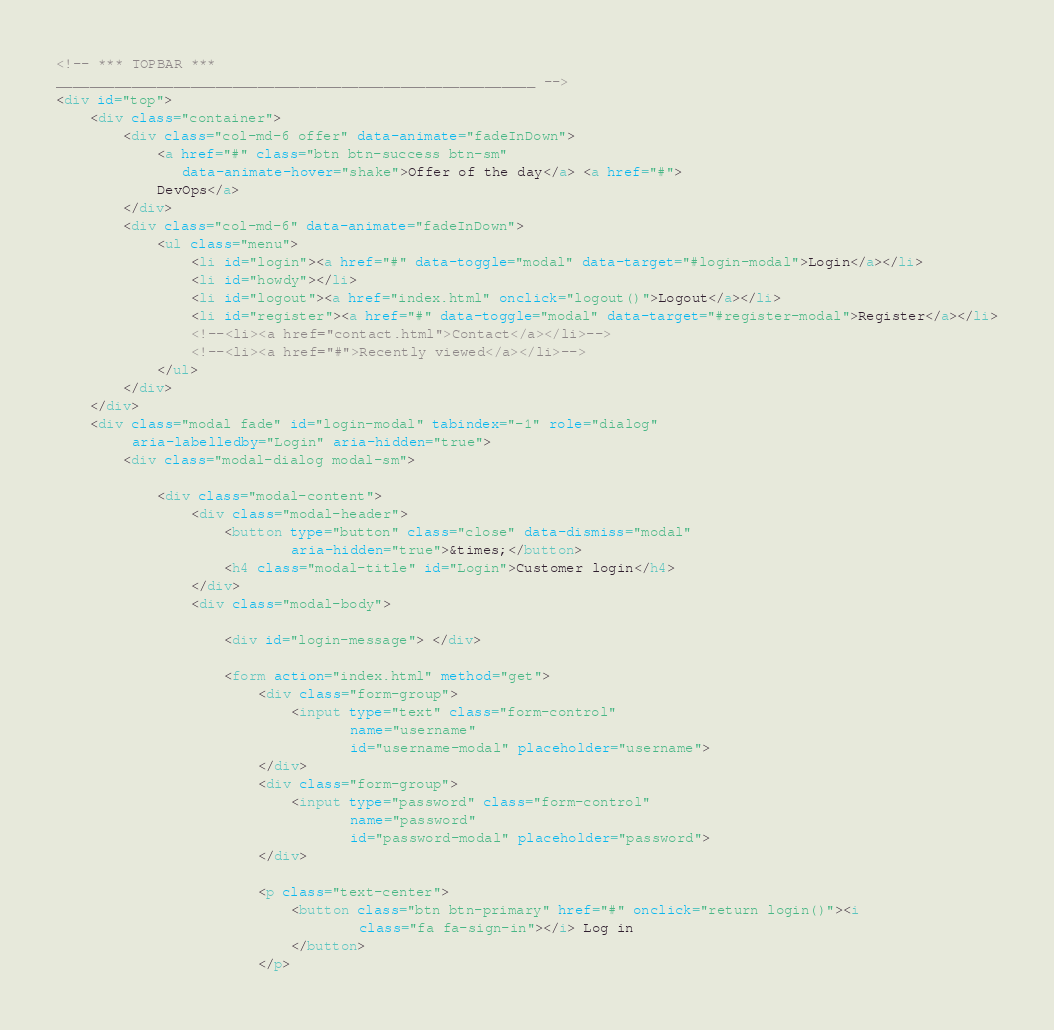<code> <loc_0><loc_0><loc_500><loc_500><_HTML_><!-- *** TOPBAR ***
_________________________________________________________ -->
<div id="top">
    <div class="container">
        <div class="col-md-6 offer" data-animate="fadeInDown">
            <a href="#" class="btn btn-success btn-sm"
               data-animate-hover="shake">Offer of the day</a> <a href="#">
            DevOps</a>
        </div>
        <div class="col-md-6" data-animate="fadeInDown">
            <ul class="menu">
                <li id="login"><a href="#" data-toggle="modal" data-target="#login-modal">Login</a></li>
                <li id="howdy"></li>
                <li id="logout"><a href="index.html" onclick="logout()">Logout</a></li>
                <li id="register"><a href="#" data-toggle="modal" data-target="#register-modal">Register</a></li>
                <!--<li><a href="contact.html">Contact</a></li>-->
                <!--<li><a href="#">Recently viewed</a></li>-->
            </ul>
        </div>
    </div>
    <div class="modal fade" id="login-modal" tabindex="-1" role="dialog"
         aria-labelledby="Login" aria-hidden="true">
        <div class="modal-dialog modal-sm">

            <div class="modal-content">
                <div class="modal-header">
                    <button type="button" class="close" data-dismiss="modal"
                            aria-hidden="true">&times;</button>
                    <h4 class="modal-title" id="Login">Customer login</h4>
                </div>
                <div class="modal-body">

                    <div id="login-message"> </div>

                    <form action="index.html" method="get">
                        <div class="form-group">
                            <input type="text" class="form-control"
                                   name="username"
                                   id="username-modal" placeholder="username">
                        </div>
                        <div class="form-group">
                            <input type="password" class="form-control"
                                   name="password"
                                   id="password-modal" placeholder="password">
                        </div>

                        <p class="text-center">
                            <button class="btn btn-primary" href="#" onclick="return login()"><i
                                    class="fa fa-sign-in"></i> Log in
                            </button>
                        </p>
</code> 